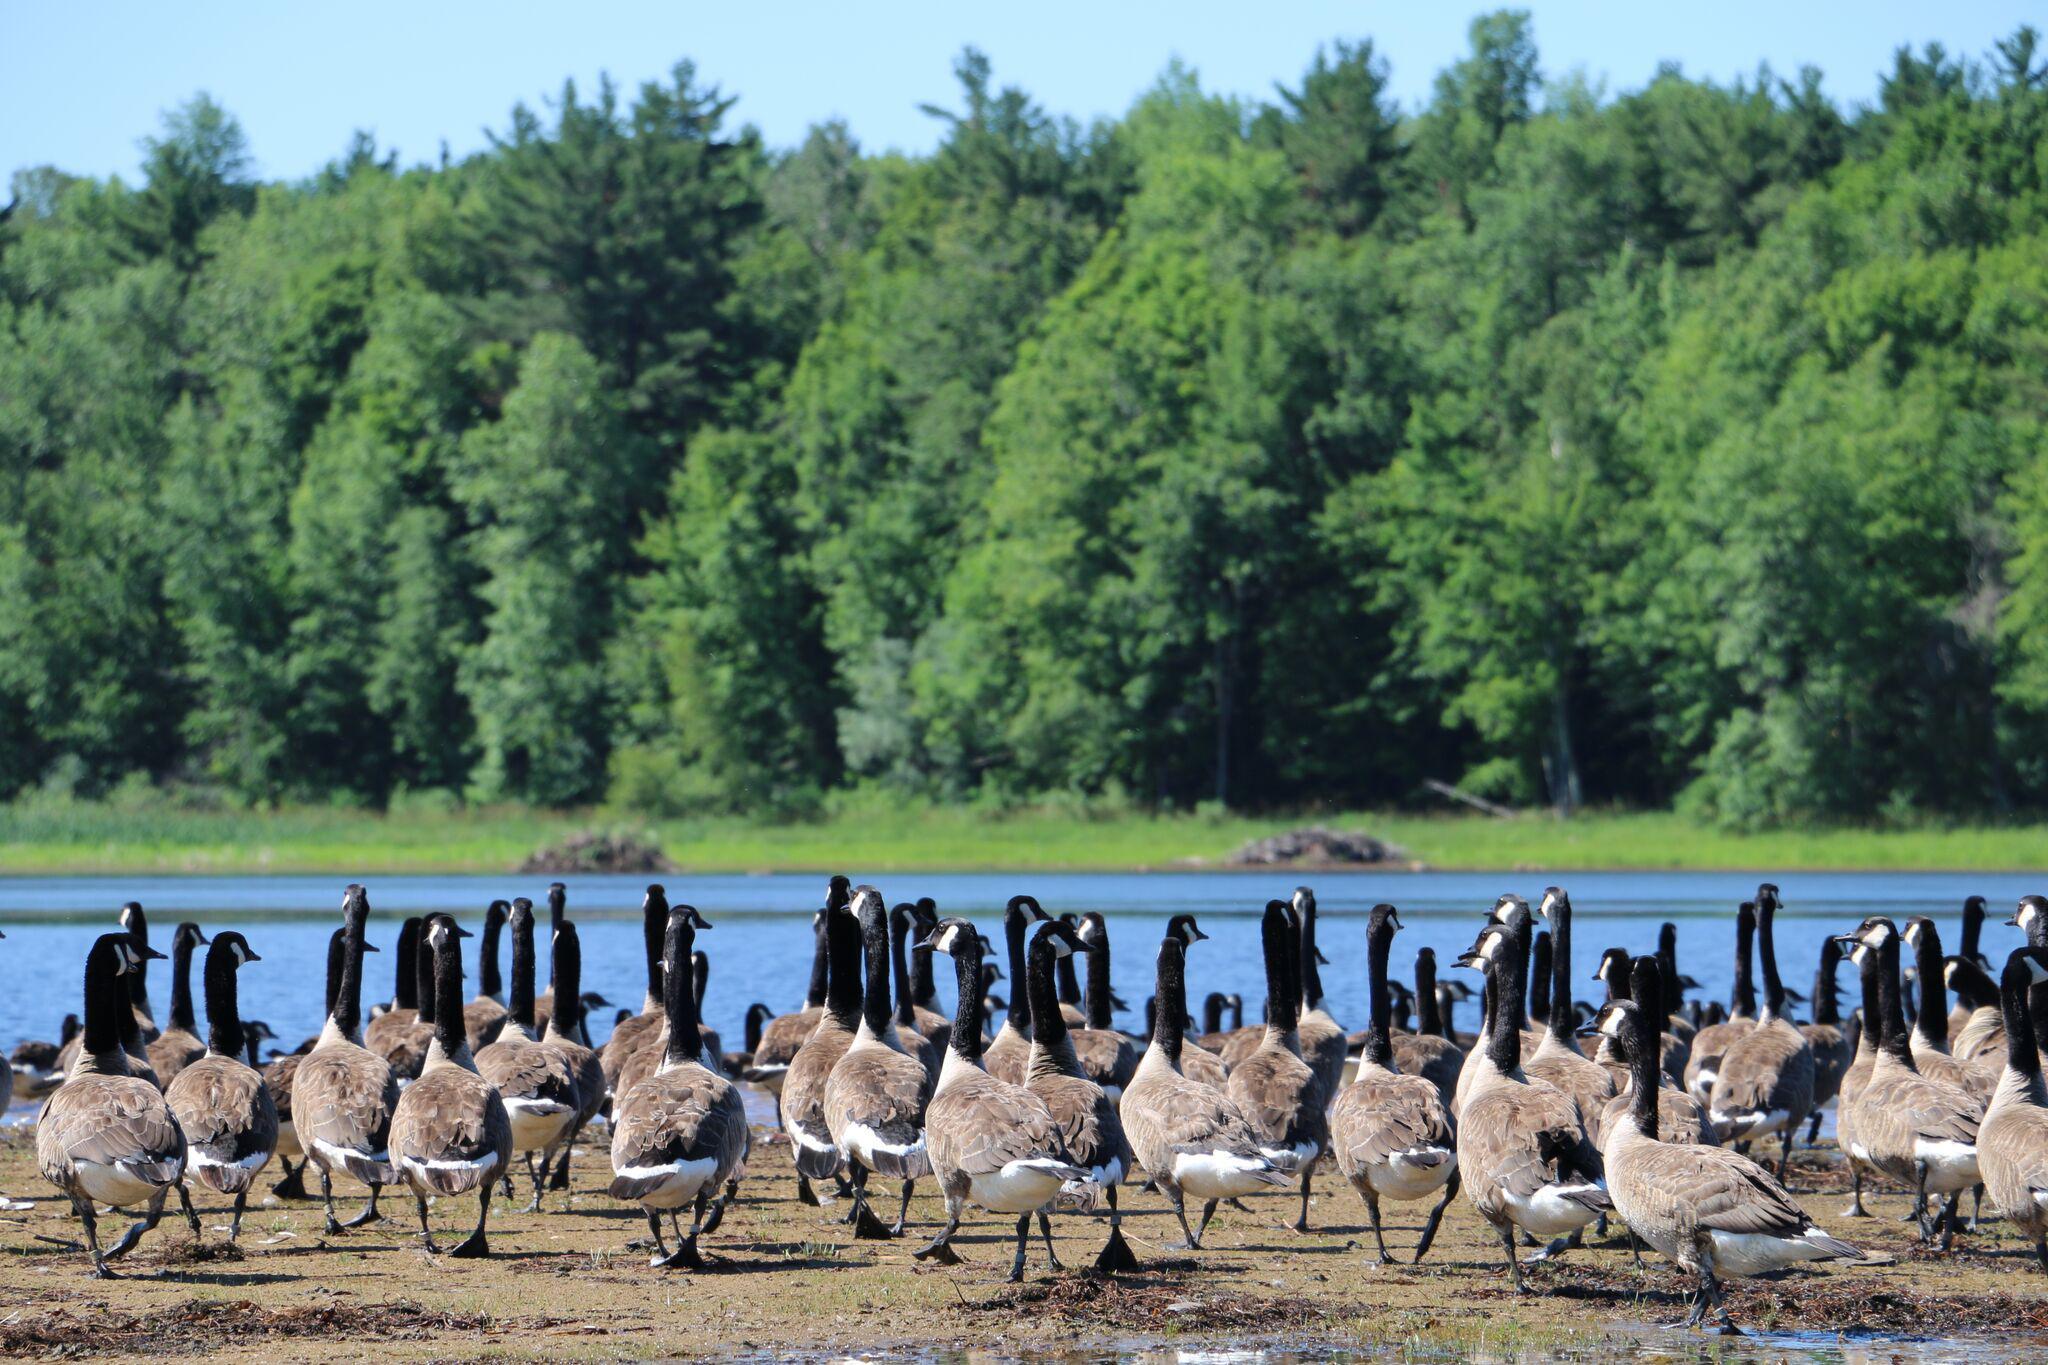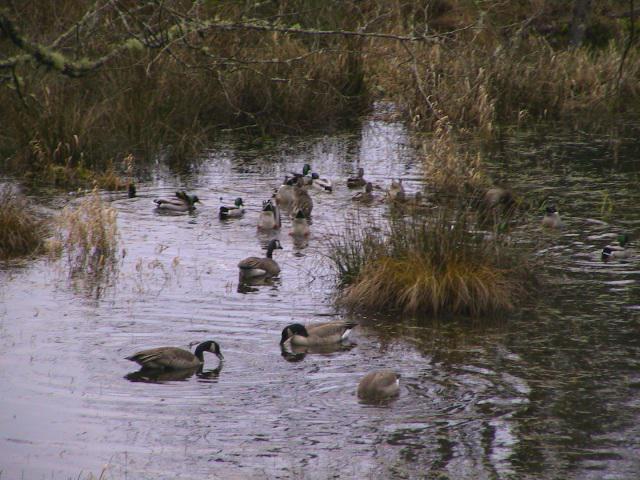The first image is the image on the left, the second image is the image on the right. Considering the images on both sides, is "The canada geese are in the water." valid? Answer yes or no. Yes. The first image is the image on the left, the second image is the image on the right. For the images displayed, is the sentence "In at least one image there is at least one black and grey duck facing right in the water." factually correct? Answer yes or no. Yes. 